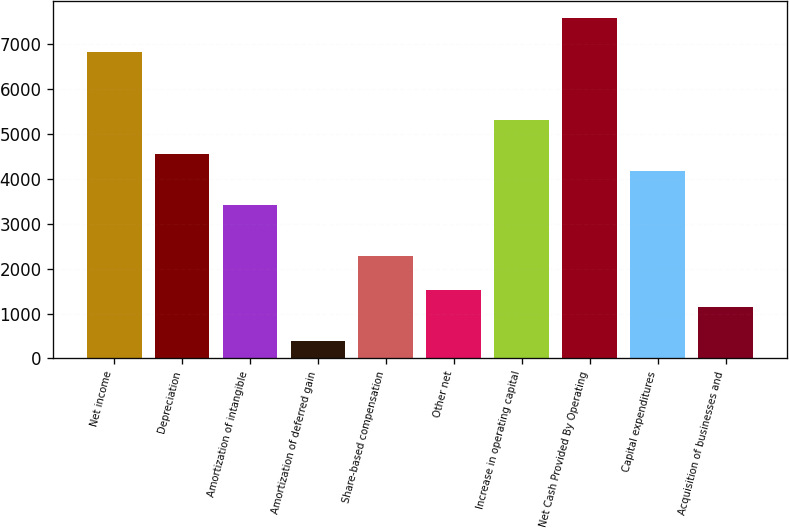Convert chart to OTSL. <chart><loc_0><loc_0><loc_500><loc_500><bar_chart><fcel>Net income<fcel>Depreciation<fcel>Amortization of intangible<fcel>Amortization of deferred gain<fcel>Share-based compensation<fcel>Other net<fcel>Increase in operating capital<fcel>Net Cash Provided By Operating<fcel>Capital expenditures<fcel>Acquisition of businesses and<nl><fcel>6824.24<fcel>4553.06<fcel>3417.47<fcel>389.23<fcel>2281.88<fcel>1524.82<fcel>5310.12<fcel>7581.3<fcel>4174.53<fcel>1146.29<nl></chart> 